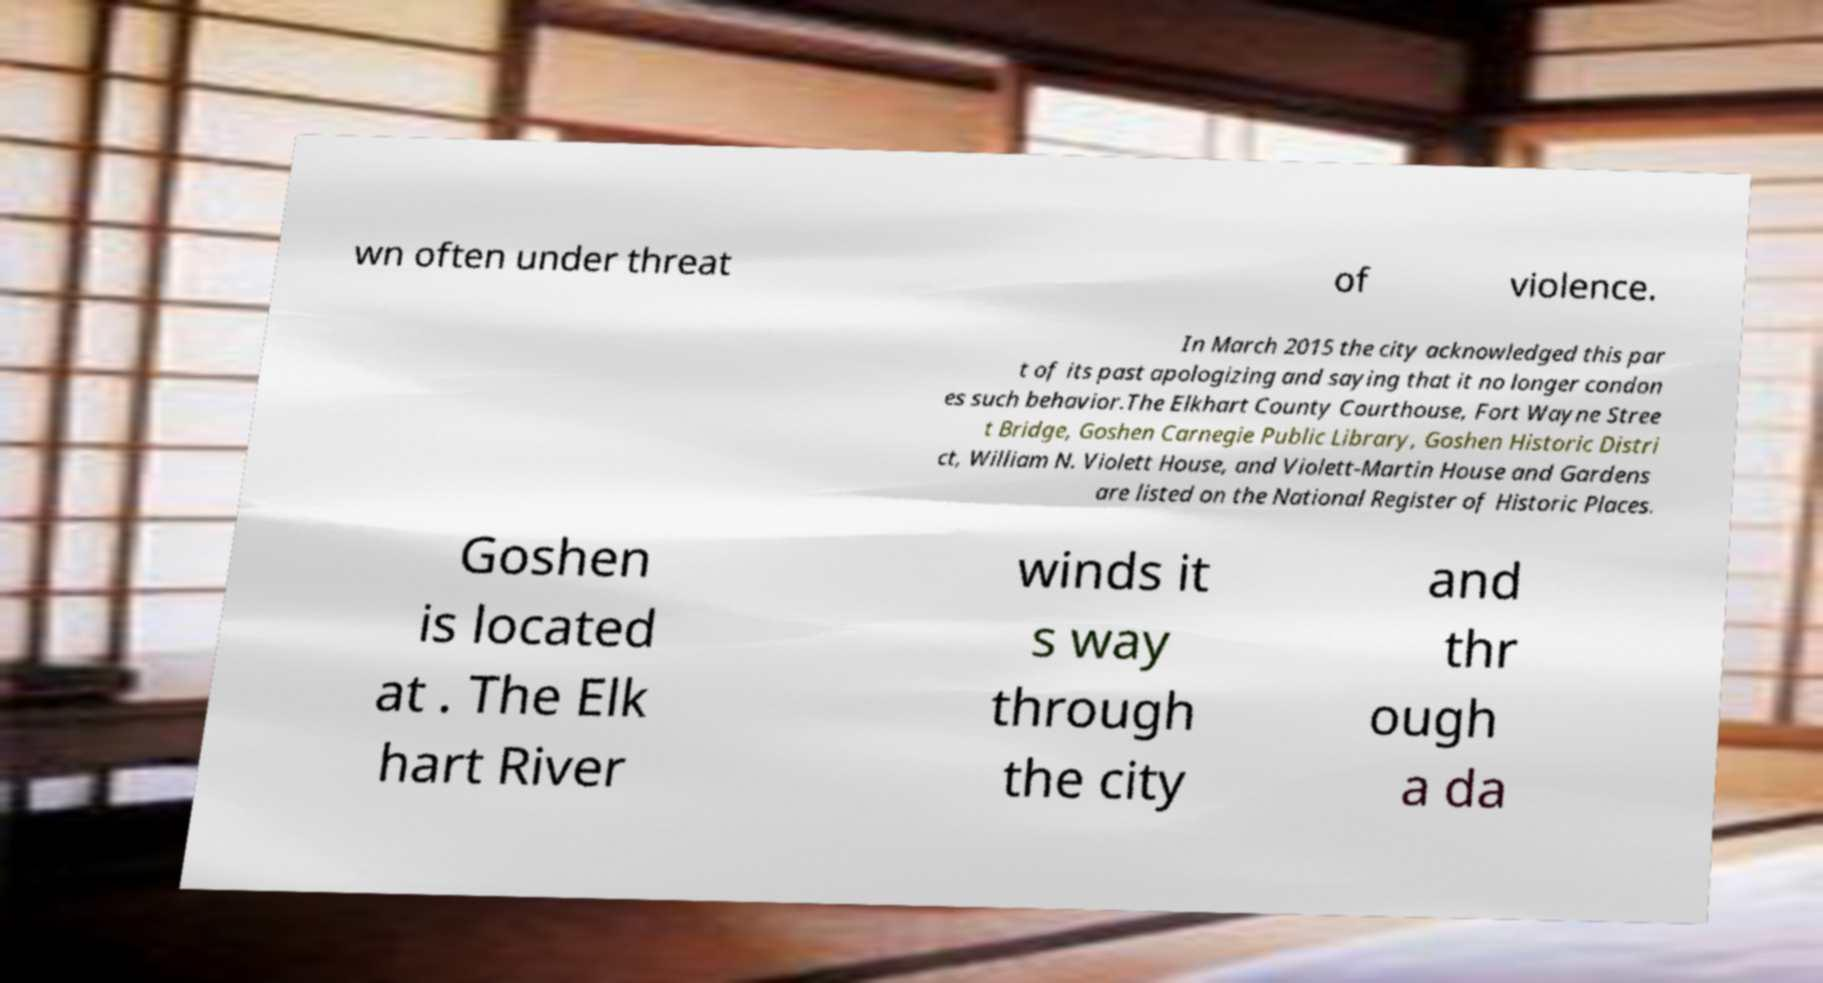Can you accurately transcribe the text from the provided image for me? wn often under threat of violence. In March 2015 the city acknowledged this par t of its past apologizing and saying that it no longer condon es such behavior.The Elkhart County Courthouse, Fort Wayne Stree t Bridge, Goshen Carnegie Public Library, Goshen Historic Distri ct, William N. Violett House, and Violett-Martin House and Gardens are listed on the National Register of Historic Places. Goshen is located at . The Elk hart River winds it s way through the city and thr ough a da 